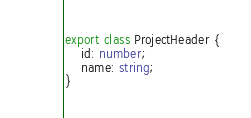Convert code to text. <code><loc_0><loc_0><loc_500><loc_500><_TypeScript_>export class ProjectHeader {
    id: number;
    name: string;
}
</code> 